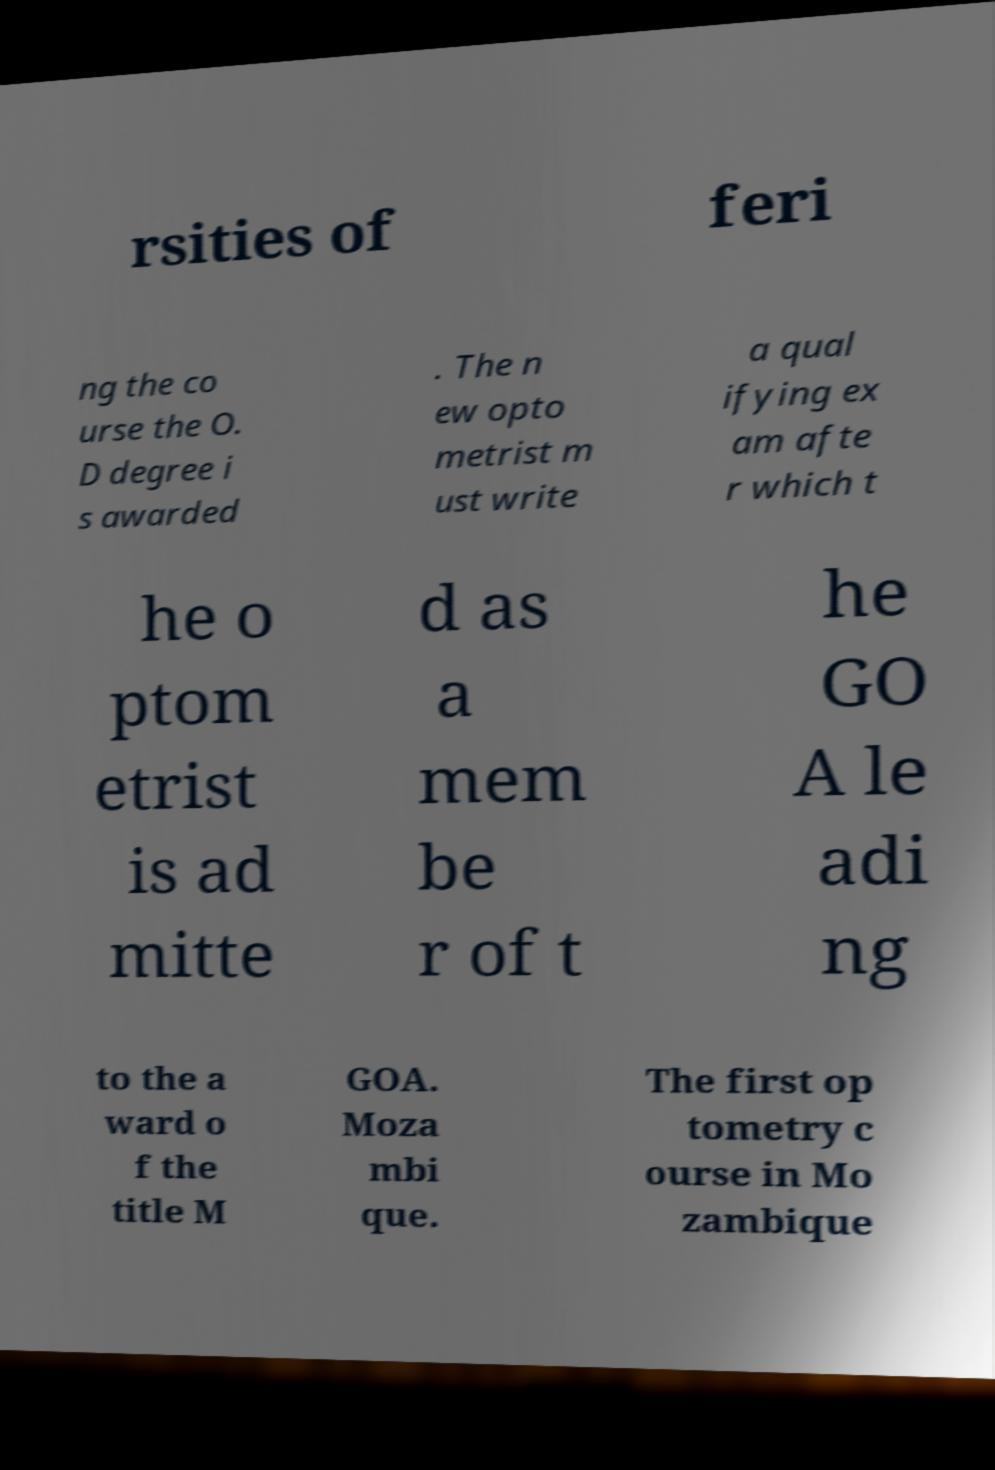For documentation purposes, I need the text within this image transcribed. Could you provide that? rsities of feri ng the co urse the O. D degree i s awarded . The n ew opto metrist m ust write a qual ifying ex am afte r which t he o ptom etrist is ad mitte d as a mem be r of t he GO A le adi ng to the a ward o f the title M GOA. Moza mbi que. The first op tometry c ourse in Mo zambique 